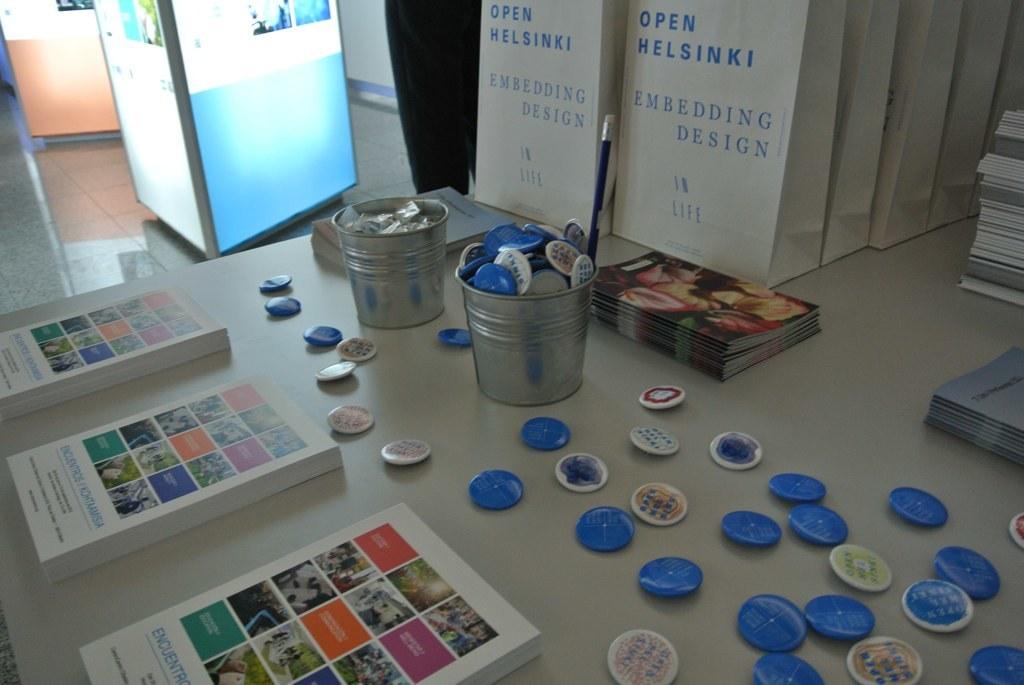What is the design called on these bags?
Give a very brief answer. Embedding. 